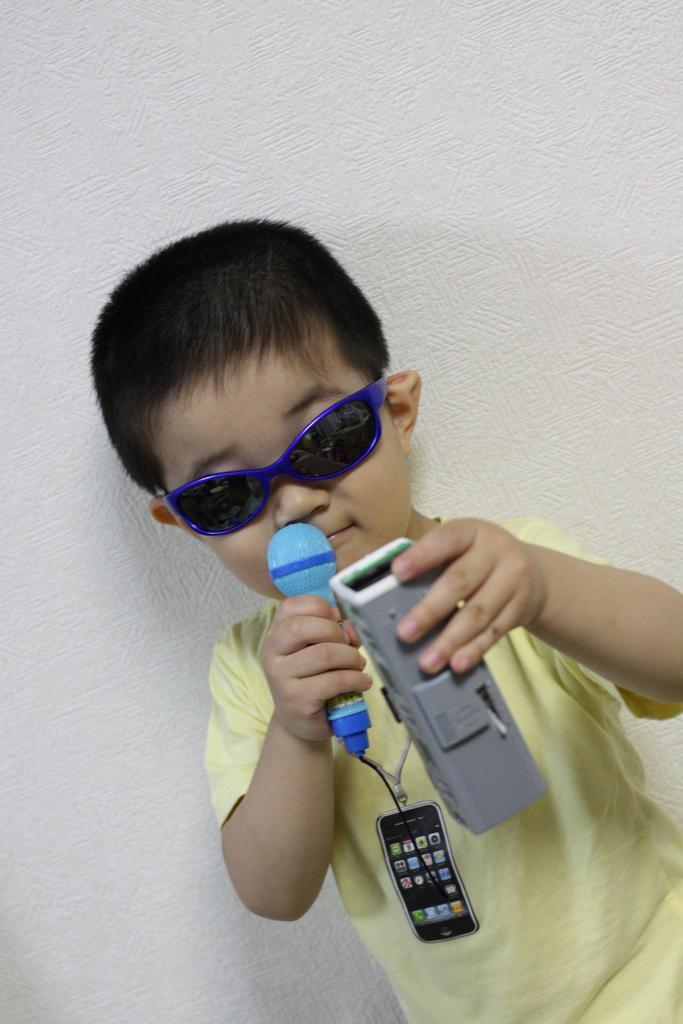Please provide a concise description of this image. A boy is standing wearing goggles and holding a blue microphone and an object in his hand. There is a white wall behind him. 